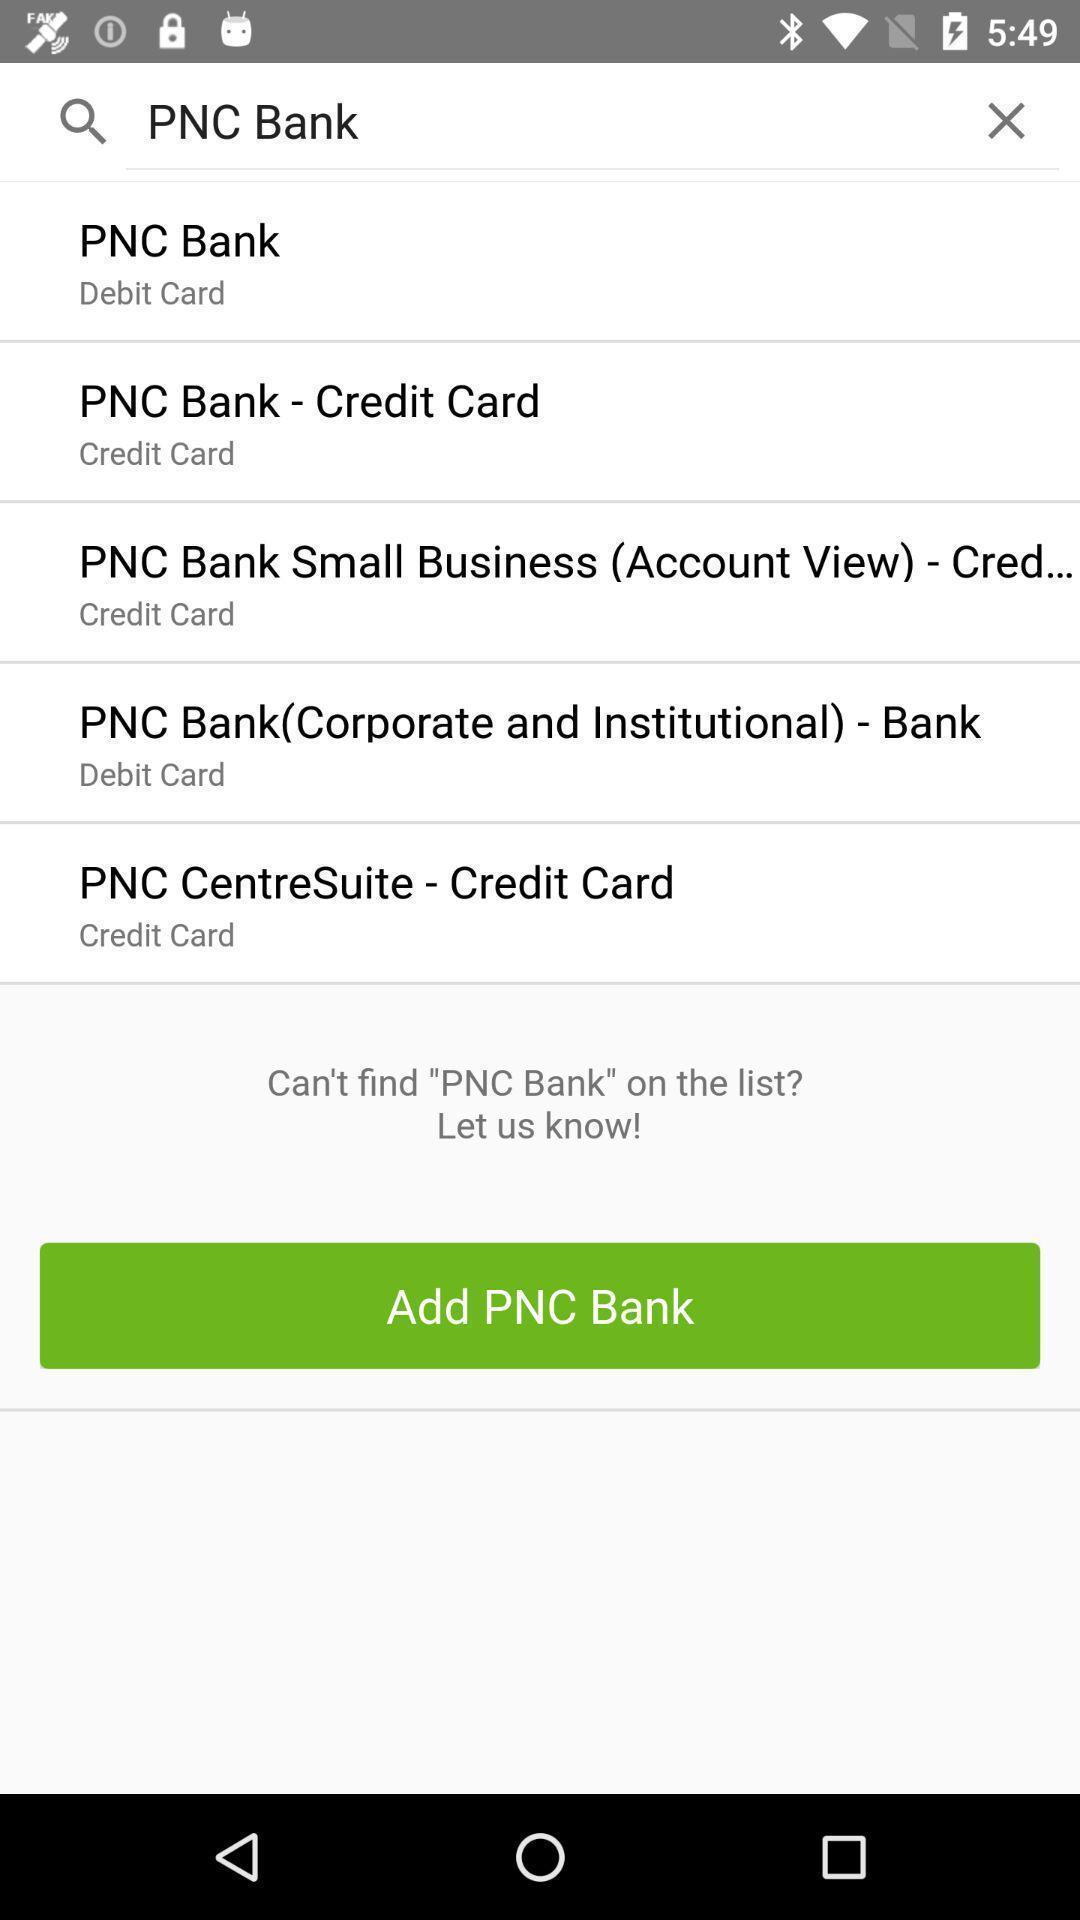Please provide a description for this image. Search results. 